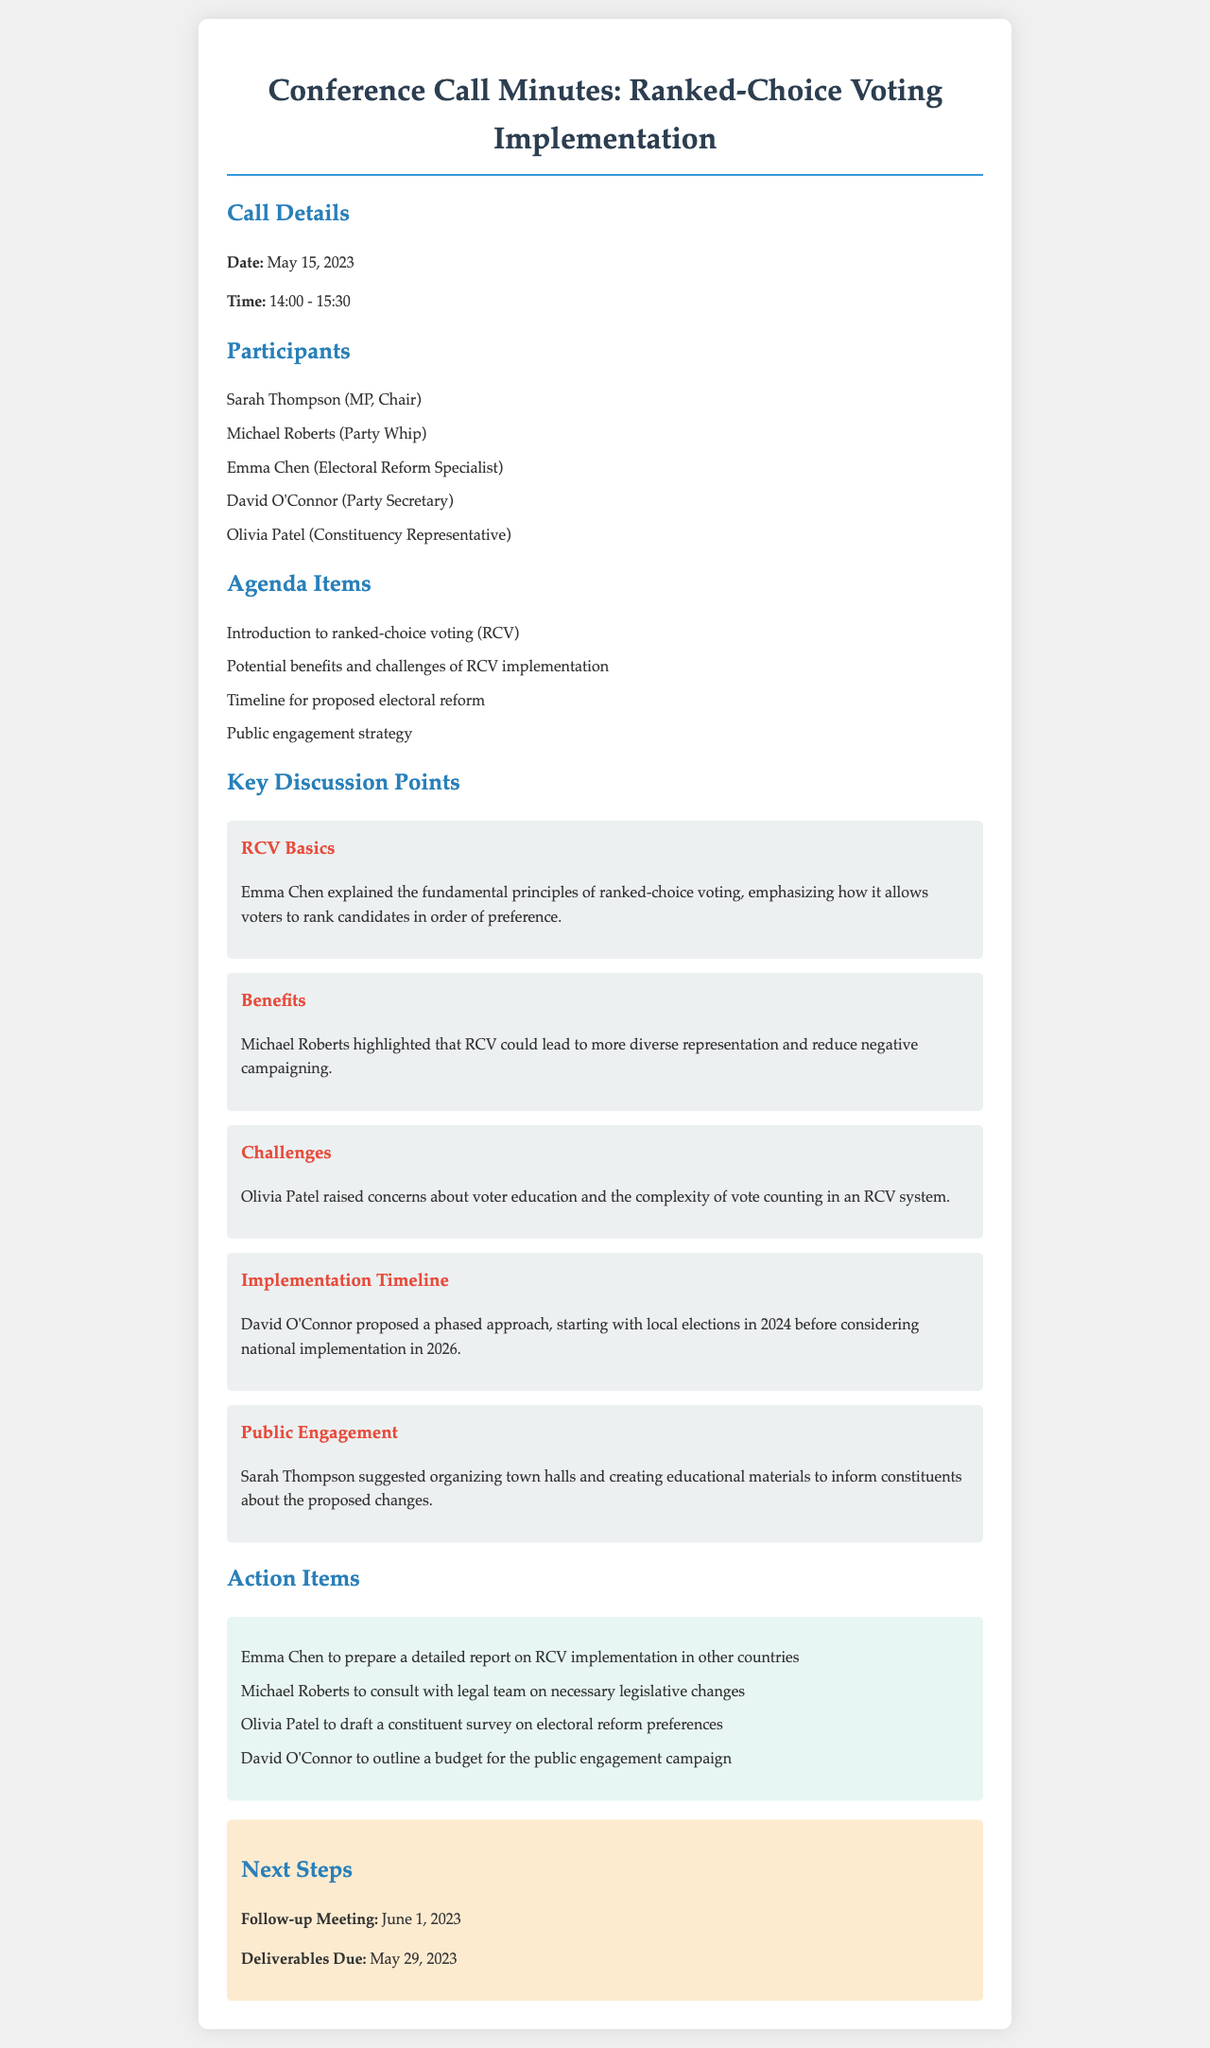What date did the conference call occur? The date of the conference call is specified in the document as May 15, 2023.
Answer: May 15, 2023 Who chaired the conference call? The document lists Sarah Thompson as the Chair of the call.
Answer: Sarah Thompson What is one potential benefit of ranked-choice voting mentioned? The document states that RCV could lead to more diverse representation.
Answer: Diverse representation What is a concern raised regarding RCV implementation? The document indicates that Olivia Patel raised concerns about voter education.
Answer: Voter education When is the follow-up meeting scheduled? The follow-up meeting date is provided in the document as June 1, 2023.
Answer: June 1, 2023 What action item is assigned to Emma Chen? The document states that Emma Chen is to prepare a report on RCV implementation in other countries.
Answer: Prepare a detailed report What year is proposed for local elections to start implementing RCV? The document mentions that local elections are proposed to start in 2024.
Answer: 2024 Who suggested organizing town halls for public engagement? Sarah Thompson is noted in the document as suggesting town halls for public engagement.
Answer: Sarah Thompson What is the proposed national implementation year for RCV? The document specifies that national implementation is considered for 2026.
Answer: 2026 